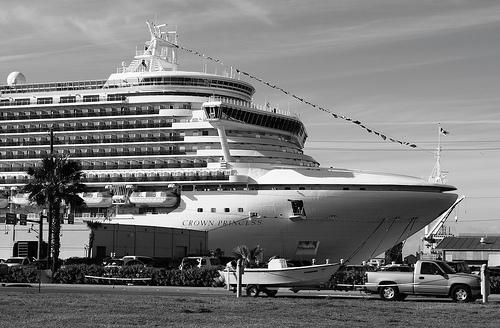How many boats are there?
Give a very brief answer. 1. 